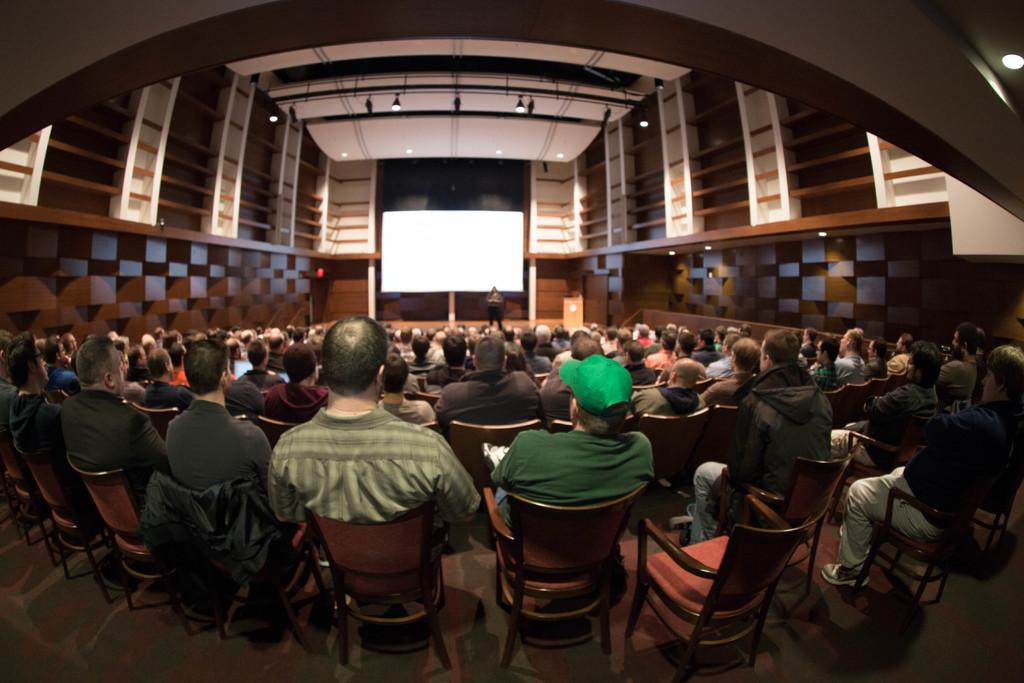What are the people in the image doing? There is a group of people sitting in chairs. Is there anyone else in the image besides the people sitting in chairs? Yes, there is a person standing in front of the group. What can be seen in the background behind the people? There is a white screen in the background. What type of stick is being used by the person standing in front of the group? There is no stick visible in the image; the person standing in front of the group is not holding or using any stick. 